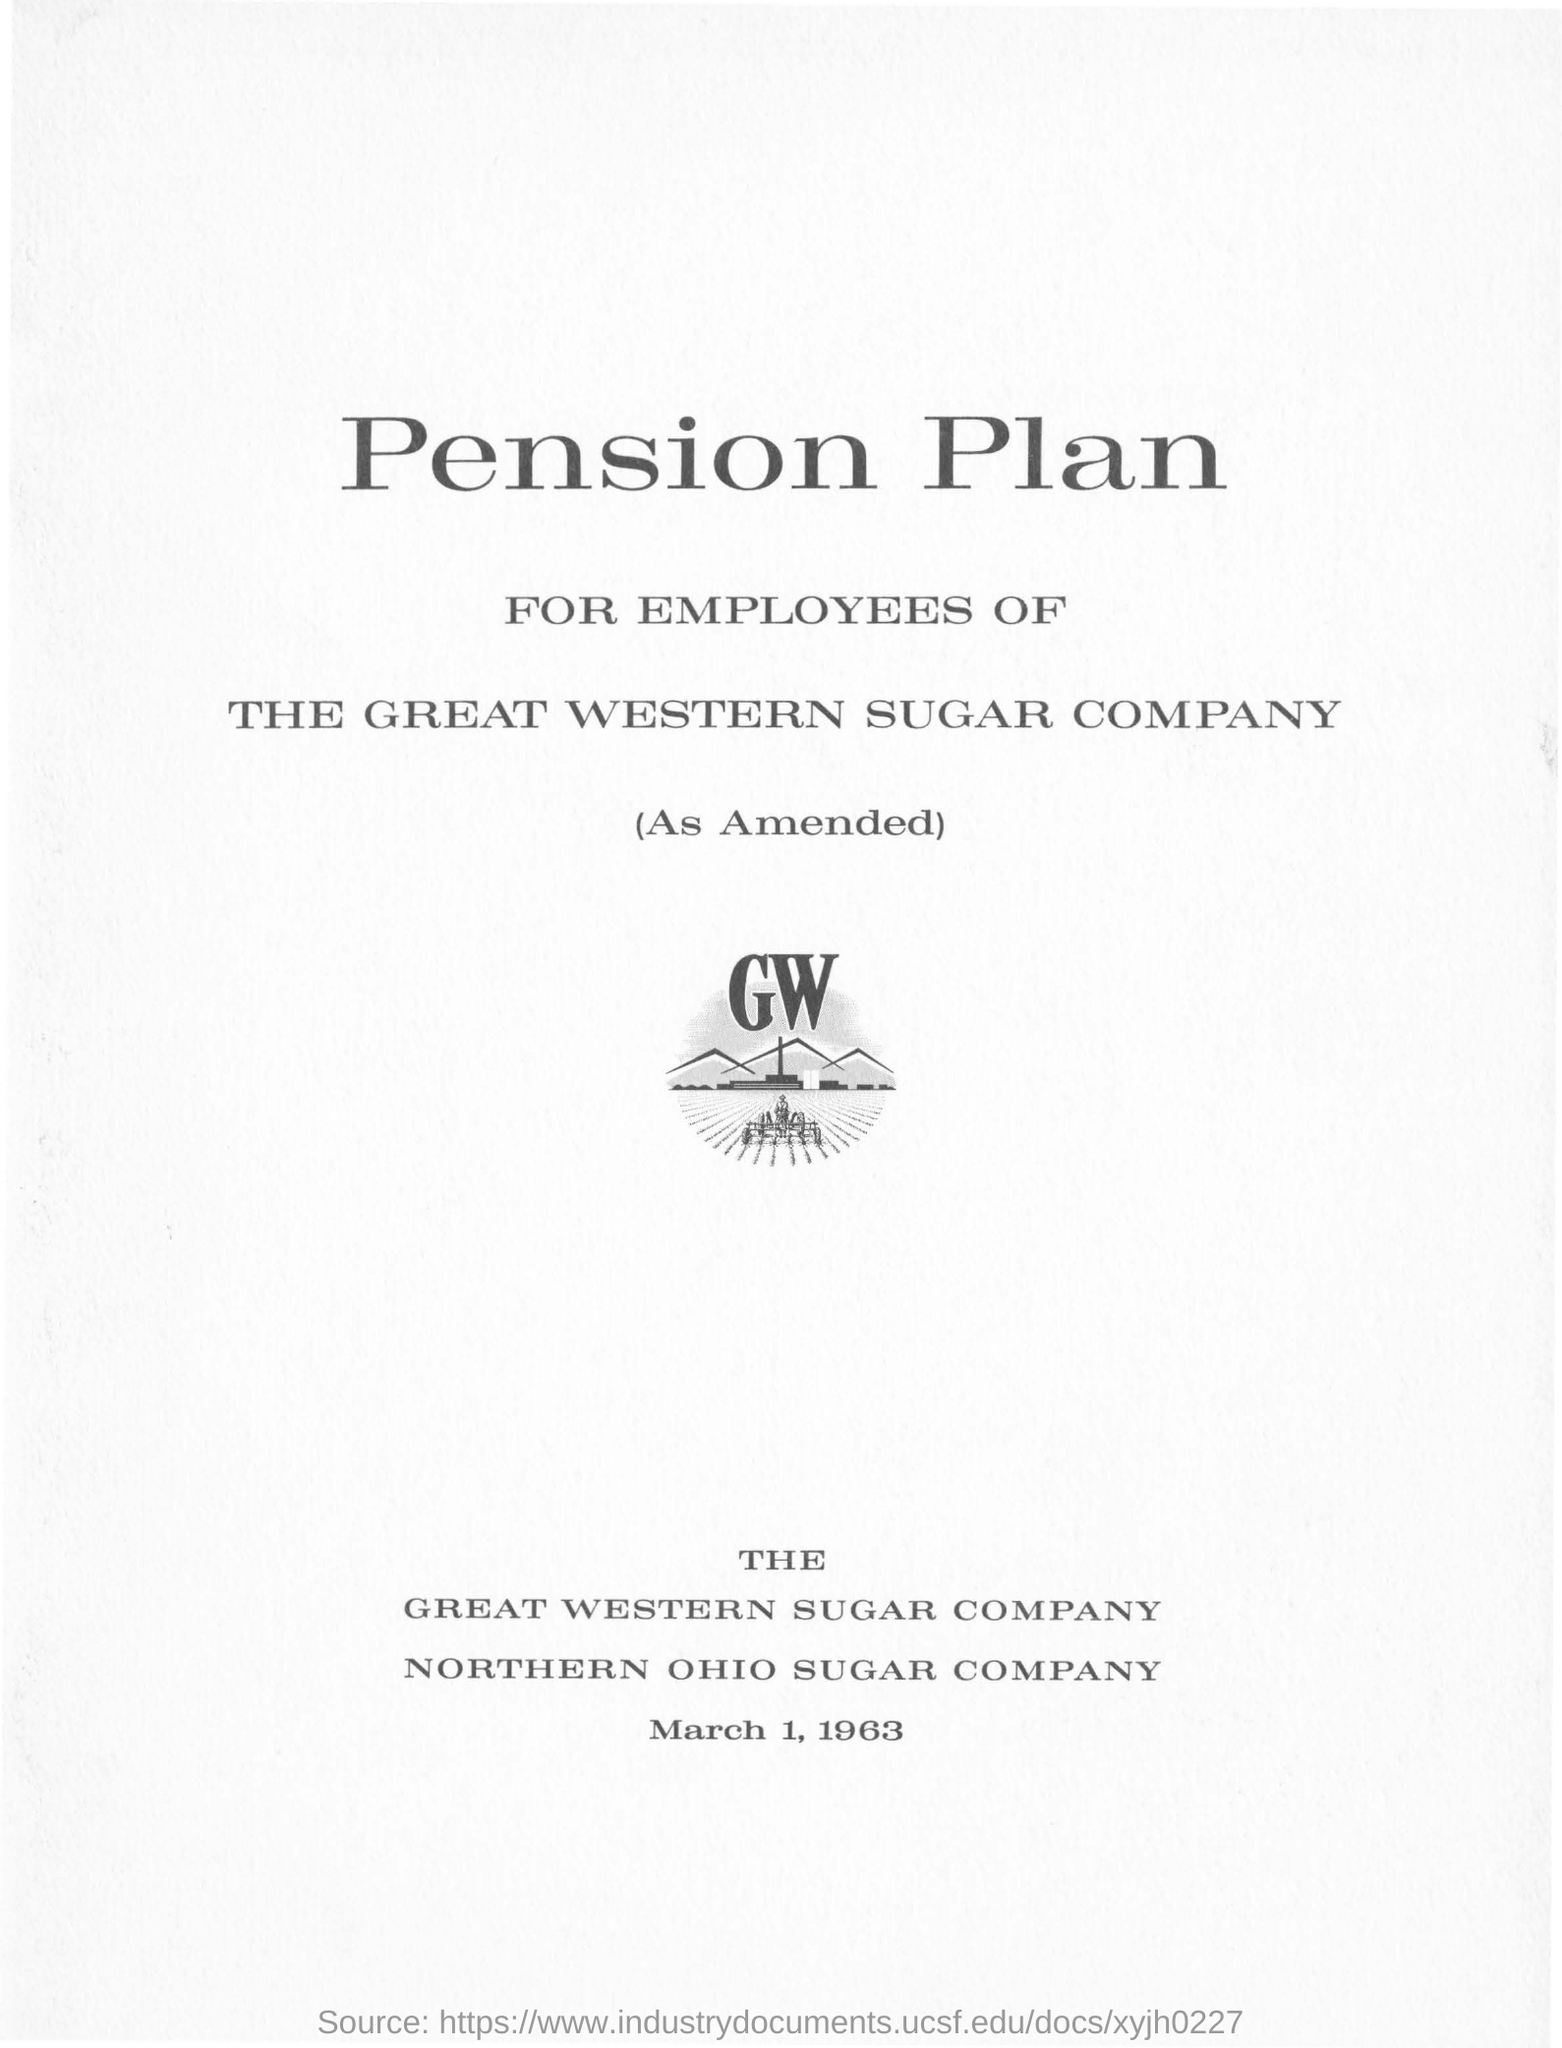Outline some significant characteristics in this image. The pension plan is exclusively for the employees of the Great Western Sugar Company. The document is dated March 1, 1963. 